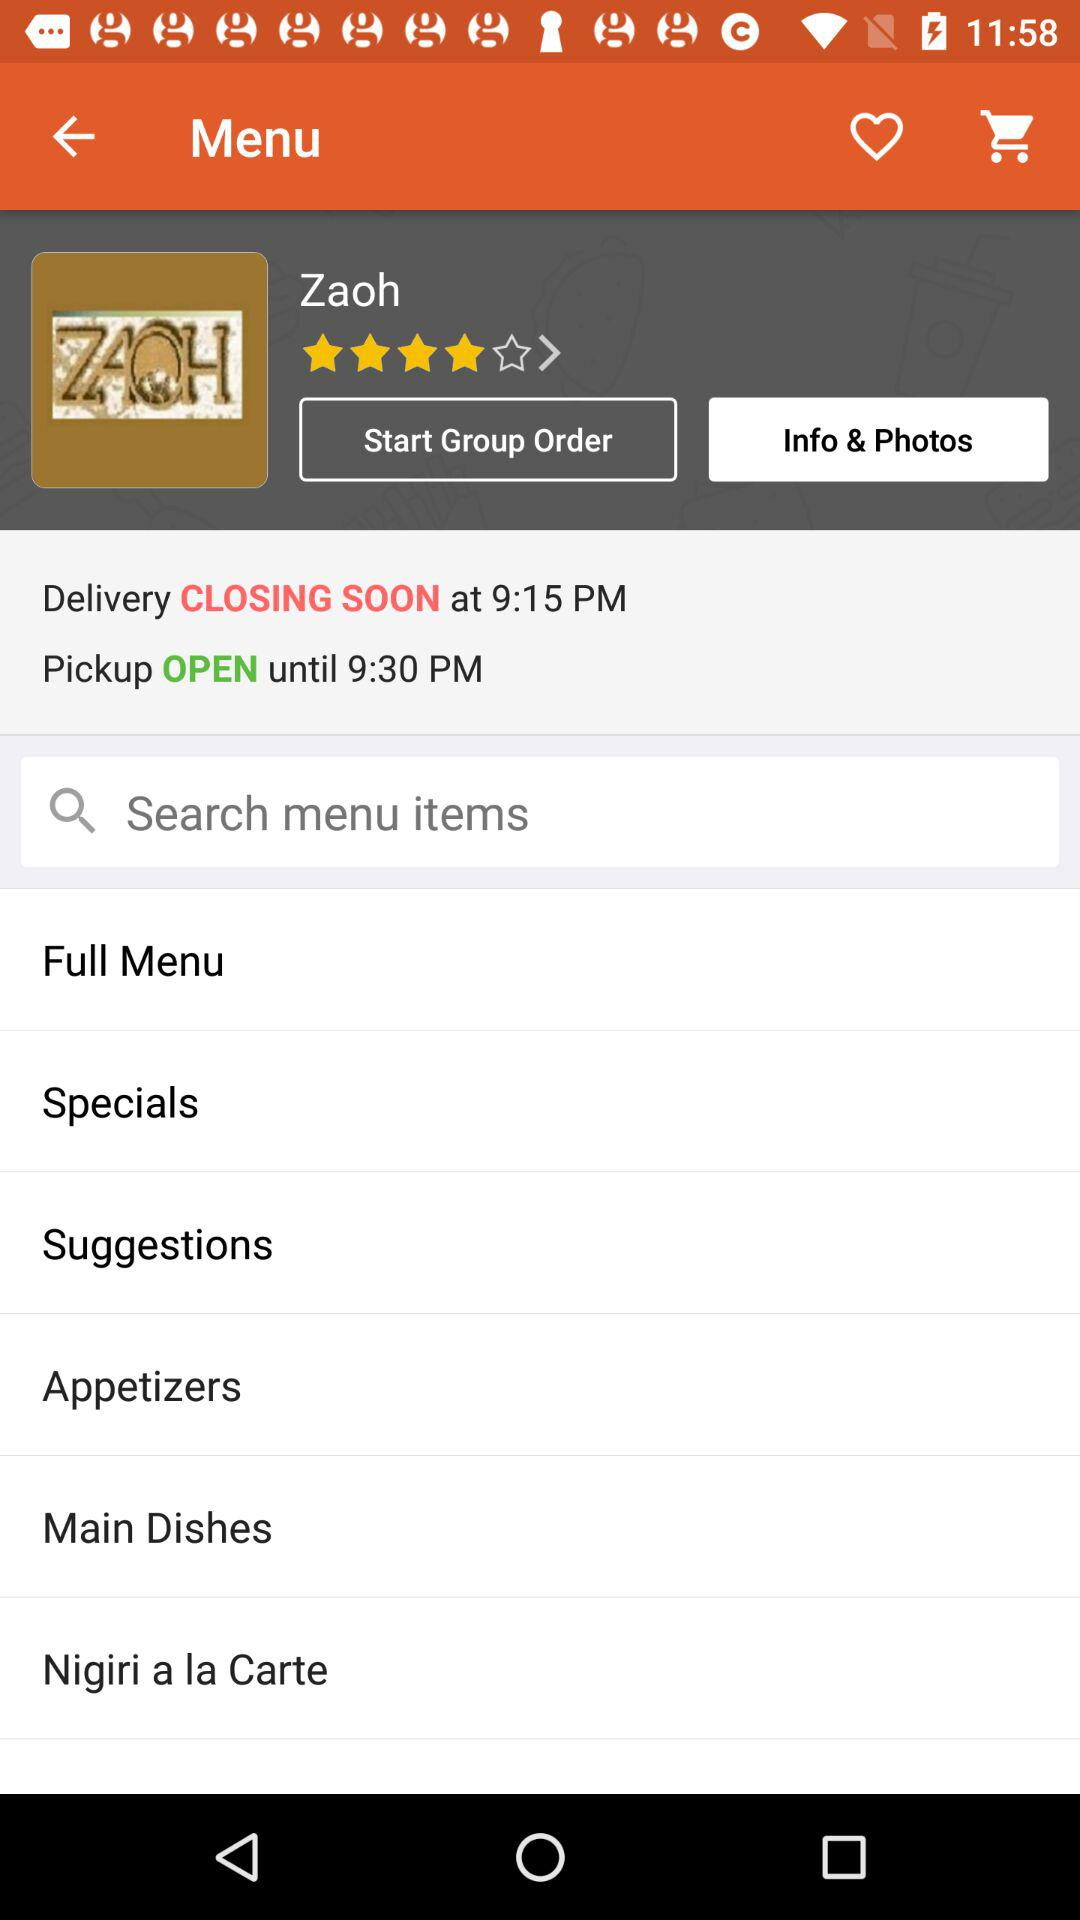What is the "Delivery CLOSING SOON" timing? The "Delivery CLOSING SOON" time is 9:15 PM. 